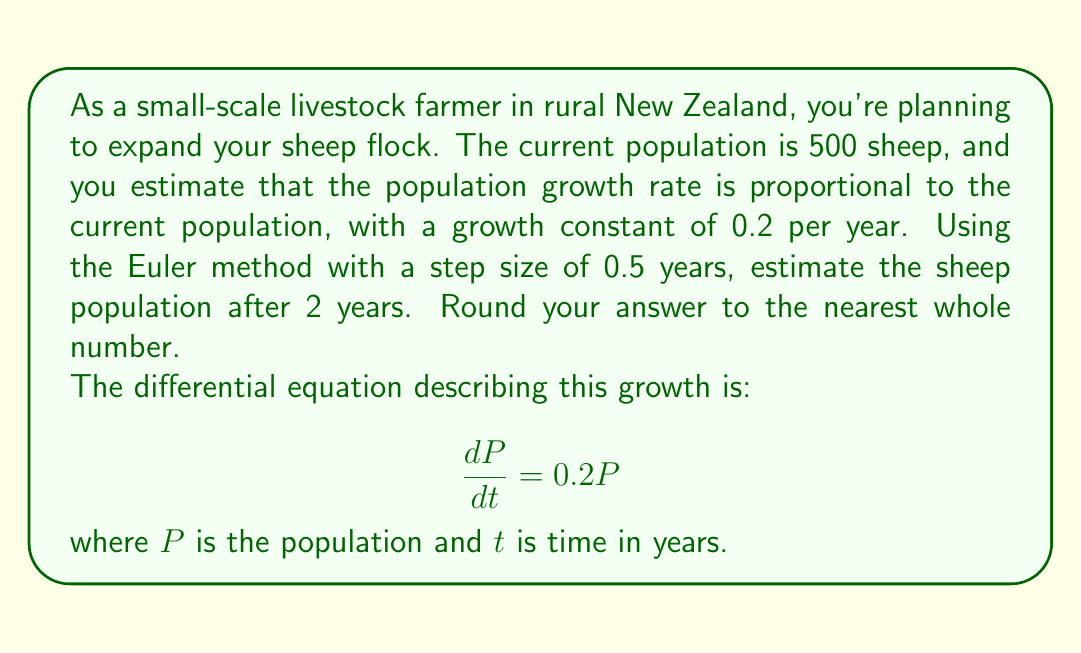Help me with this question. To solve this problem, we'll use the Euler method for numerical approximation of differential equations. The Euler method is given by:

$$P_{n+1} = P_n + h \cdot f(t_n, P_n)$$

where $h$ is the step size, $P_n$ is the population at time $t_n$, and $f(t_n, P_n)$ is the right-hand side of the differential equation.

Given:
- Initial population $P_0 = 500$
- Growth rate $k = 0.2$ per year
- Step size $h = 0.5$ years
- Time to forecast $t = 2$ years

We need to perform 4 steps (2 years / 0.5 years per step = 4 steps).

Step 1 (t = 0.5 years):
$P_1 = P_0 + h \cdot (0.2P_0) = 500 + 0.5 \cdot (0.2 \cdot 500) = 550$

Step 2 (t = 1 year):
$P_2 = P_1 + h \cdot (0.2P_1) = 550 + 0.5 \cdot (0.2 \cdot 550) = 605$

Step 3 (t = 1.5 years):
$P_3 = P_2 + h \cdot (0.2P_2) = 605 + 0.5 \cdot (0.2 \cdot 605) = 665.5$

Step 4 (t = 2 years):
$P_4 = P_3 + h \cdot (0.2P_3) = 665.5 + 0.5 \cdot (0.2 \cdot 665.5) = 732.05$

Rounding to the nearest whole number, we get 732 sheep.
Answer: 732 sheep 